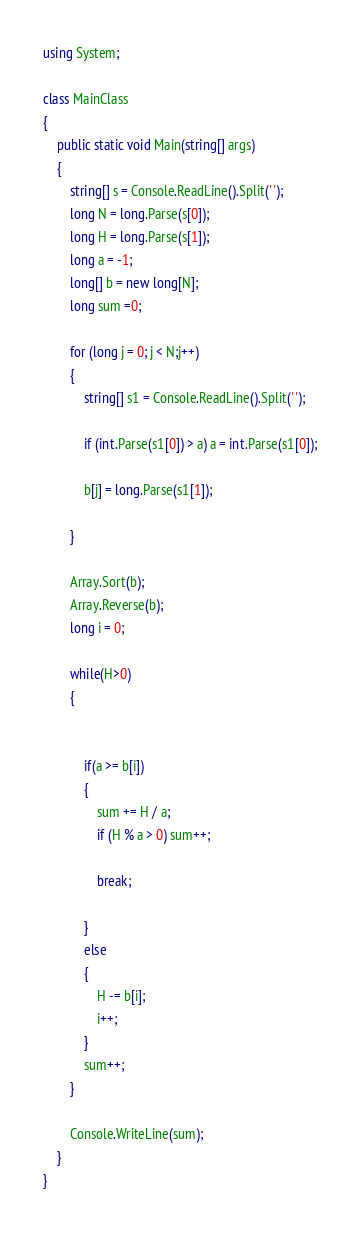Convert code to text. <code><loc_0><loc_0><loc_500><loc_500><_C#_>using System;

class MainClass
{
    public static void Main(string[] args)
    {
        string[] s = Console.ReadLine().Split(' ');
        long N = long.Parse(s[0]);
        long H = long.Parse(s[1]);
        long a = -1;
        long[] b = new long[N];
        long sum =0;

        for (long j = 0; j < N;j++)
        {
            string[] s1 = Console.ReadLine().Split(' ');

            if (int.Parse(s1[0]) > a) a = int.Parse(s1[0]);

            b[j] = long.Parse(s1[1]);

        }

        Array.Sort(b);
        Array.Reverse(b);
        long i = 0;

        while(H>0)
        {


            if(a >= b[i])
            {
                sum += H / a;
                if (H % a > 0) sum++;

                break;

            }
            else
            {
                H -= b[i];
                i++;
            }
            sum++;
        }

        Console.WriteLine(sum);
    }
}</code> 